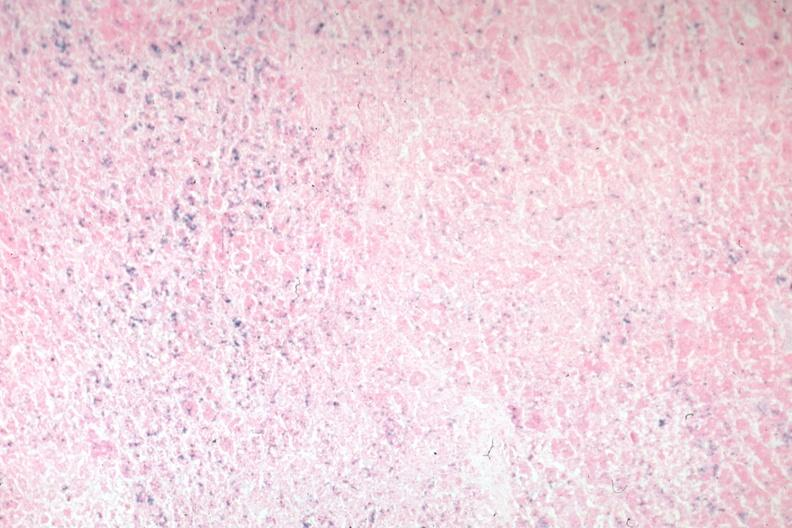s atrophy present?
Answer the question using a single word or phrase. No 